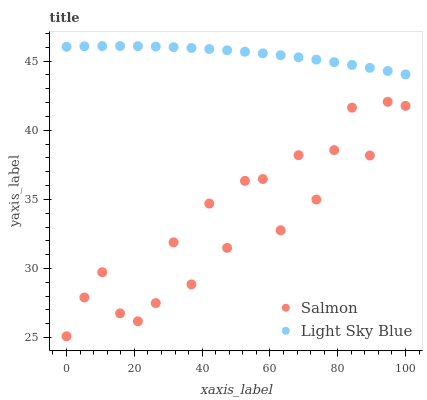Does Salmon have the minimum area under the curve?
Answer yes or no. Yes. Does Light Sky Blue have the maximum area under the curve?
Answer yes or no. Yes. Does Salmon have the maximum area under the curve?
Answer yes or no. No. Is Light Sky Blue the smoothest?
Answer yes or no. Yes. Is Salmon the roughest?
Answer yes or no. Yes. Is Salmon the smoothest?
Answer yes or no. No. Does Salmon have the lowest value?
Answer yes or no. Yes. Does Light Sky Blue have the highest value?
Answer yes or no. Yes. Does Salmon have the highest value?
Answer yes or no. No. Is Salmon less than Light Sky Blue?
Answer yes or no. Yes. Is Light Sky Blue greater than Salmon?
Answer yes or no. Yes. Does Salmon intersect Light Sky Blue?
Answer yes or no. No. 